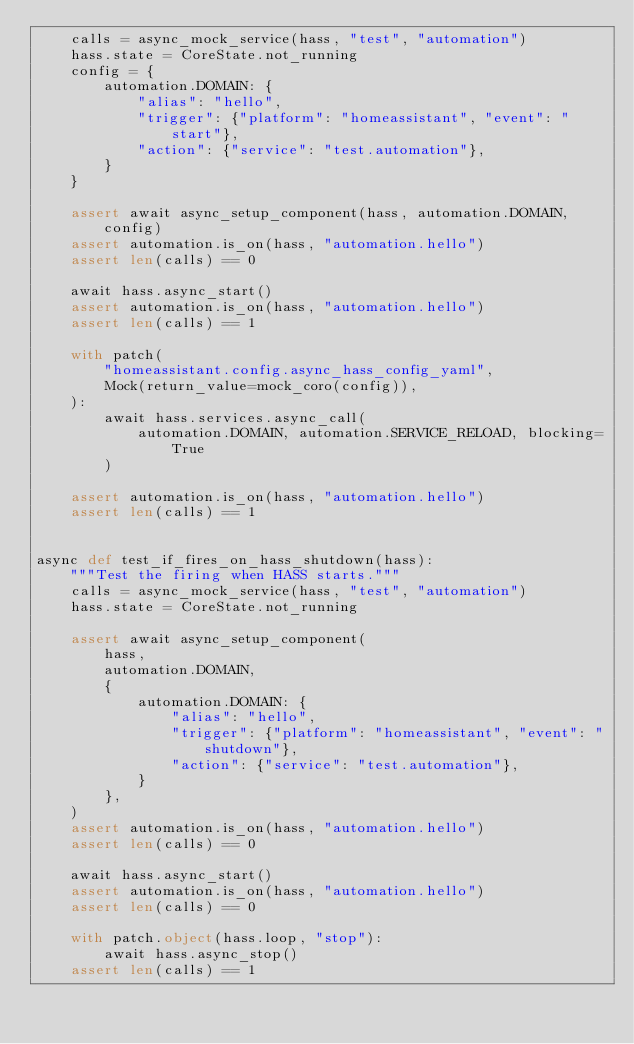<code> <loc_0><loc_0><loc_500><loc_500><_Python_>    calls = async_mock_service(hass, "test", "automation")
    hass.state = CoreState.not_running
    config = {
        automation.DOMAIN: {
            "alias": "hello",
            "trigger": {"platform": "homeassistant", "event": "start"},
            "action": {"service": "test.automation"},
        }
    }

    assert await async_setup_component(hass, automation.DOMAIN, config)
    assert automation.is_on(hass, "automation.hello")
    assert len(calls) == 0

    await hass.async_start()
    assert automation.is_on(hass, "automation.hello")
    assert len(calls) == 1

    with patch(
        "homeassistant.config.async_hass_config_yaml",
        Mock(return_value=mock_coro(config)),
    ):
        await hass.services.async_call(
            automation.DOMAIN, automation.SERVICE_RELOAD, blocking=True
        )

    assert automation.is_on(hass, "automation.hello")
    assert len(calls) == 1


async def test_if_fires_on_hass_shutdown(hass):
    """Test the firing when HASS starts."""
    calls = async_mock_service(hass, "test", "automation")
    hass.state = CoreState.not_running

    assert await async_setup_component(
        hass,
        automation.DOMAIN,
        {
            automation.DOMAIN: {
                "alias": "hello",
                "trigger": {"platform": "homeassistant", "event": "shutdown"},
                "action": {"service": "test.automation"},
            }
        },
    )
    assert automation.is_on(hass, "automation.hello")
    assert len(calls) == 0

    await hass.async_start()
    assert automation.is_on(hass, "automation.hello")
    assert len(calls) == 0

    with patch.object(hass.loop, "stop"):
        await hass.async_stop()
    assert len(calls) == 1
</code> 